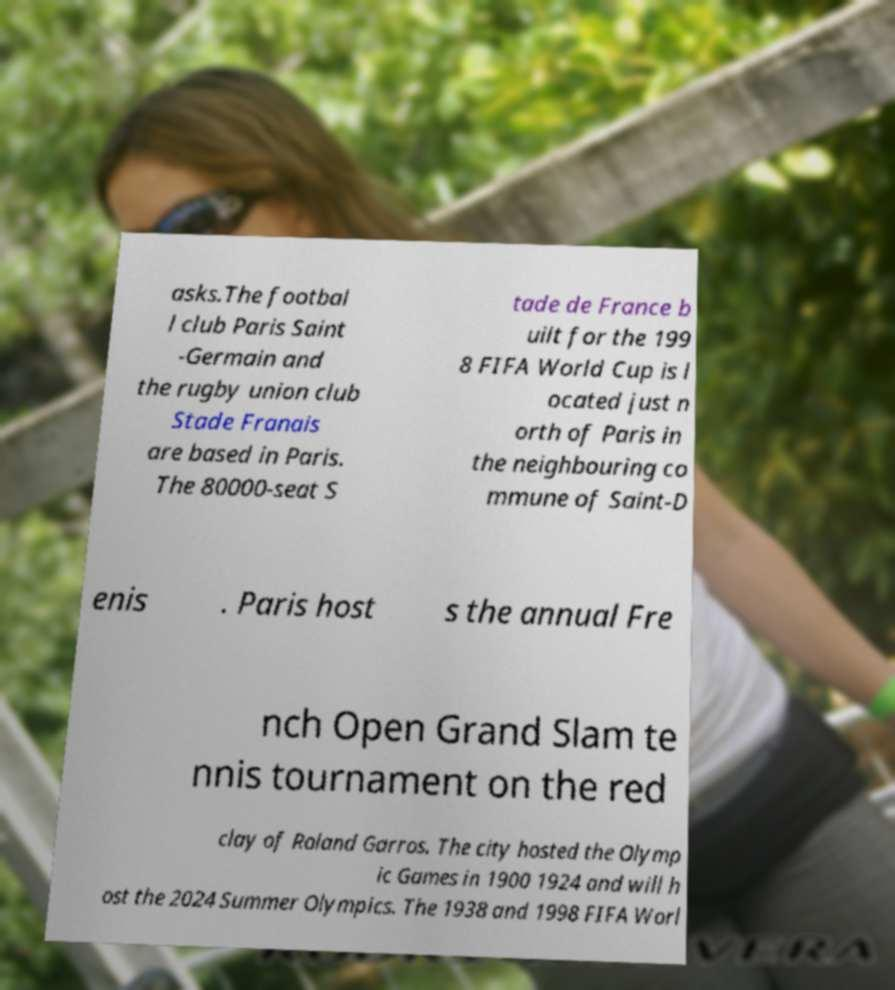Please identify and transcribe the text found in this image. asks.The footbal l club Paris Saint -Germain and the rugby union club Stade Franais are based in Paris. The 80000-seat S tade de France b uilt for the 199 8 FIFA World Cup is l ocated just n orth of Paris in the neighbouring co mmune of Saint-D enis . Paris host s the annual Fre nch Open Grand Slam te nnis tournament on the red clay of Roland Garros. The city hosted the Olymp ic Games in 1900 1924 and will h ost the 2024 Summer Olympics. The 1938 and 1998 FIFA Worl 